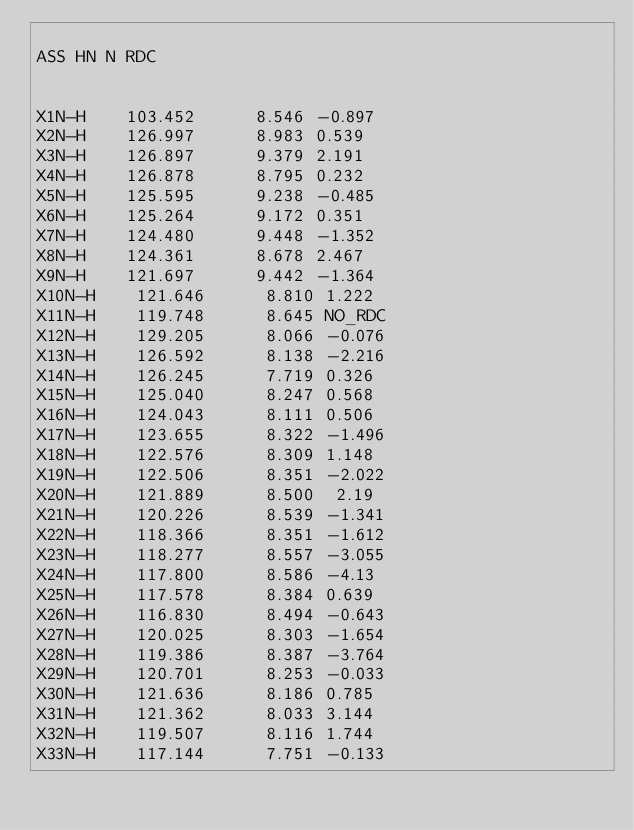<code> <loc_0><loc_0><loc_500><loc_500><_SQL_>
ASS HN N RDC


X1N-H    103.452      8.546 -0.897
X2N-H    126.997      8.983 0.539
X3N-H    126.897      9.379 2.191
X4N-H    126.878      8.795 0.232
X5N-H    125.595      9.238 -0.485
X6N-H    125.264      9.172 0.351
X7N-H    124.480      9.448 -1.352
X8N-H    124.361      8.678 2.467
X9N-H    121.697      9.442 -1.364
X10N-H    121.646      8.810 1.222
X11N-H    119.748      8.645 NO_RDC
X12N-H    129.205      8.066 -0.076
X13N-H    126.592      8.138 -2.216
X14N-H    126.245      7.719 0.326
X15N-H    125.040      8.247 0.568
X16N-H    124.043      8.111 0.506
X17N-H    123.655      8.322 -1.496
X18N-H    122.576      8.309 1.148
X19N-H    122.506      8.351 -2.022
X20N-H    121.889      8.500  2.19
X21N-H    120.226      8.539 -1.341
X22N-H    118.366      8.351 -1.612
X23N-H    118.277      8.557 -3.055
X24N-H    117.800      8.586 -4.13
X25N-H    117.578      8.384 0.639
X26N-H    116.830      8.494 -0.643
X27N-H    120.025      8.303 -1.654
X28N-H    119.386      8.387 -3.764
X29N-H    120.701      8.253 -0.033
X30N-H    121.636      8.186 0.785
X31N-H    121.362      8.033 3.144
X32N-H    119.507      8.116 1.744
X33N-H    117.144      7.751 -0.133</code> 